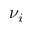<formula> <loc_0><loc_0><loc_500><loc_500>\nu _ { i }</formula> 